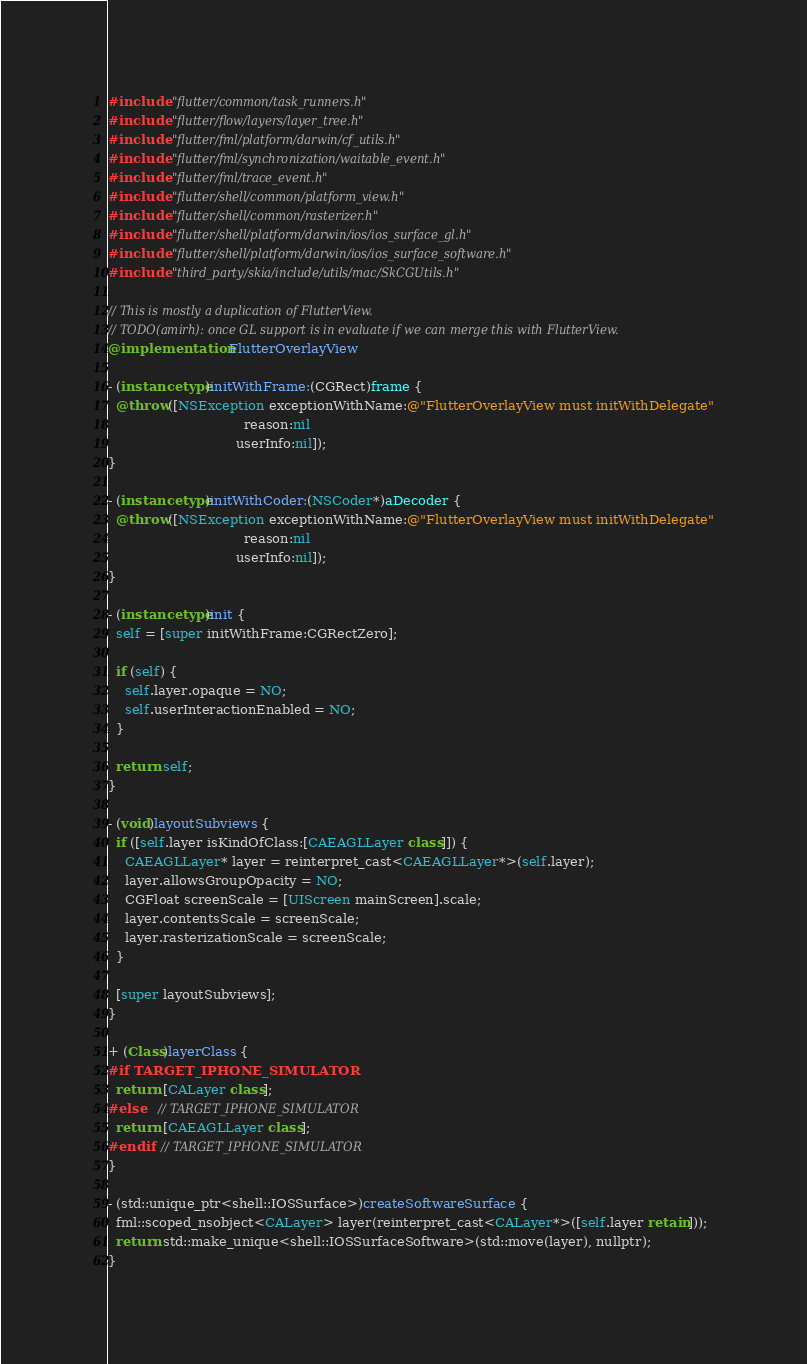Convert code to text. <code><loc_0><loc_0><loc_500><loc_500><_ObjectiveC_>#include "flutter/common/task_runners.h"
#include "flutter/flow/layers/layer_tree.h"
#include "flutter/fml/platform/darwin/cf_utils.h"
#include "flutter/fml/synchronization/waitable_event.h"
#include "flutter/fml/trace_event.h"
#include "flutter/shell/common/platform_view.h"
#include "flutter/shell/common/rasterizer.h"
#include "flutter/shell/platform/darwin/ios/ios_surface_gl.h"
#include "flutter/shell/platform/darwin/ios/ios_surface_software.h"
#include "third_party/skia/include/utils/mac/SkCGUtils.h"

// This is mostly a duplication of FlutterView.
// TODO(amirh): once GL support is in evaluate if we can merge this with FlutterView.
@implementation FlutterOverlayView

- (instancetype)initWithFrame:(CGRect)frame {
  @throw([NSException exceptionWithName:@"FlutterOverlayView must initWithDelegate"
                                 reason:nil
                               userInfo:nil]);
}

- (instancetype)initWithCoder:(NSCoder*)aDecoder {
  @throw([NSException exceptionWithName:@"FlutterOverlayView must initWithDelegate"
                                 reason:nil
                               userInfo:nil]);
}

- (instancetype)init {
  self = [super initWithFrame:CGRectZero];

  if (self) {
    self.layer.opaque = NO;
    self.userInteractionEnabled = NO;
  }

  return self;
}

- (void)layoutSubviews {
  if ([self.layer isKindOfClass:[CAEAGLLayer class]]) {
    CAEAGLLayer* layer = reinterpret_cast<CAEAGLLayer*>(self.layer);
    layer.allowsGroupOpacity = NO;
    CGFloat screenScale = [UIScreen mainScreen].scale;
    layer.contentsScale = screenScale;
    layer.rasterizationScale = screenScale;
  }

  [super layoutSubviews];
}

+ (Class)layerClass {
#if TARGET_IPHONE_SIMULATOR
  return [CALayer class];
#else   // TARGET_IPHONE_SIMULATOR
  return [CAEAGLLayer class];
#endif  // TARGET_IPHONE_SIMULATOR
}

- (std::unique_ptr<shell::IOSSurface>)createSoftwareSurface {
  fml::scoped_nsobject<CALayer> layer(reinterpret_cast<CALayer*>([self.layer retain]));
  return std::make_unique<shell::IOSSurfaceSoftware>(std::move(layer), nullptr);
}
</code> 